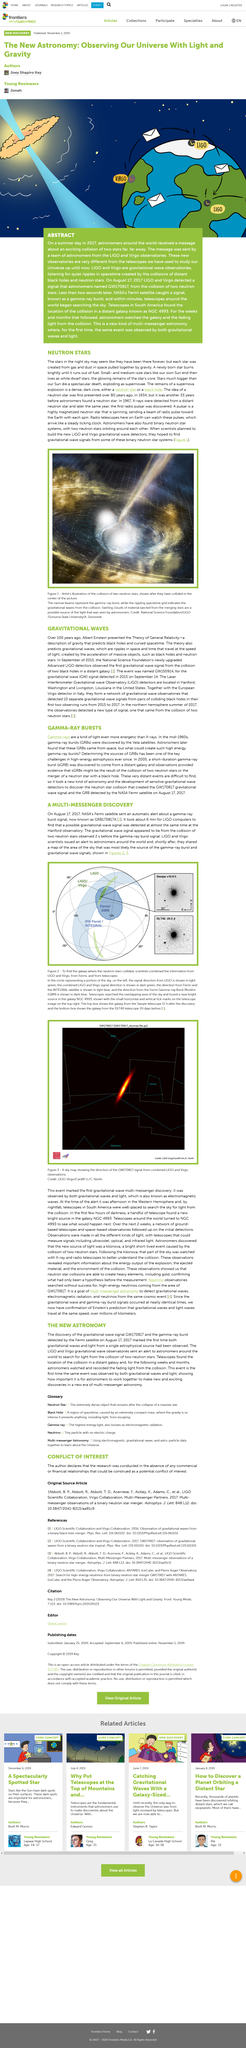Give some essential details in this illustration. According to the Theory of General Relativity, black holes and spacetime are predicted, as well as gravitational waves. The goal of multi-messenger astronomy is to detect a combination of gravitational waves, electromagnetic radiation, and neutrinos from the same cosmic event, in order to gain a more complete understanding of these phenomena and the nature of the universe. Pulsar is a highly magnetized neutron star that emits a beam of radio waves towards the Earth with each rotation, which is known as a pulsar. The light green color is used to indicate the direction of the signal from LIGO in the diagram. Recent observations by telescopes in South America have pinpointed the location of a collision between a distant galaxy known as NGC 4993 and a smaller galaxy, providing new insights into the nature of galaxy evolution. 